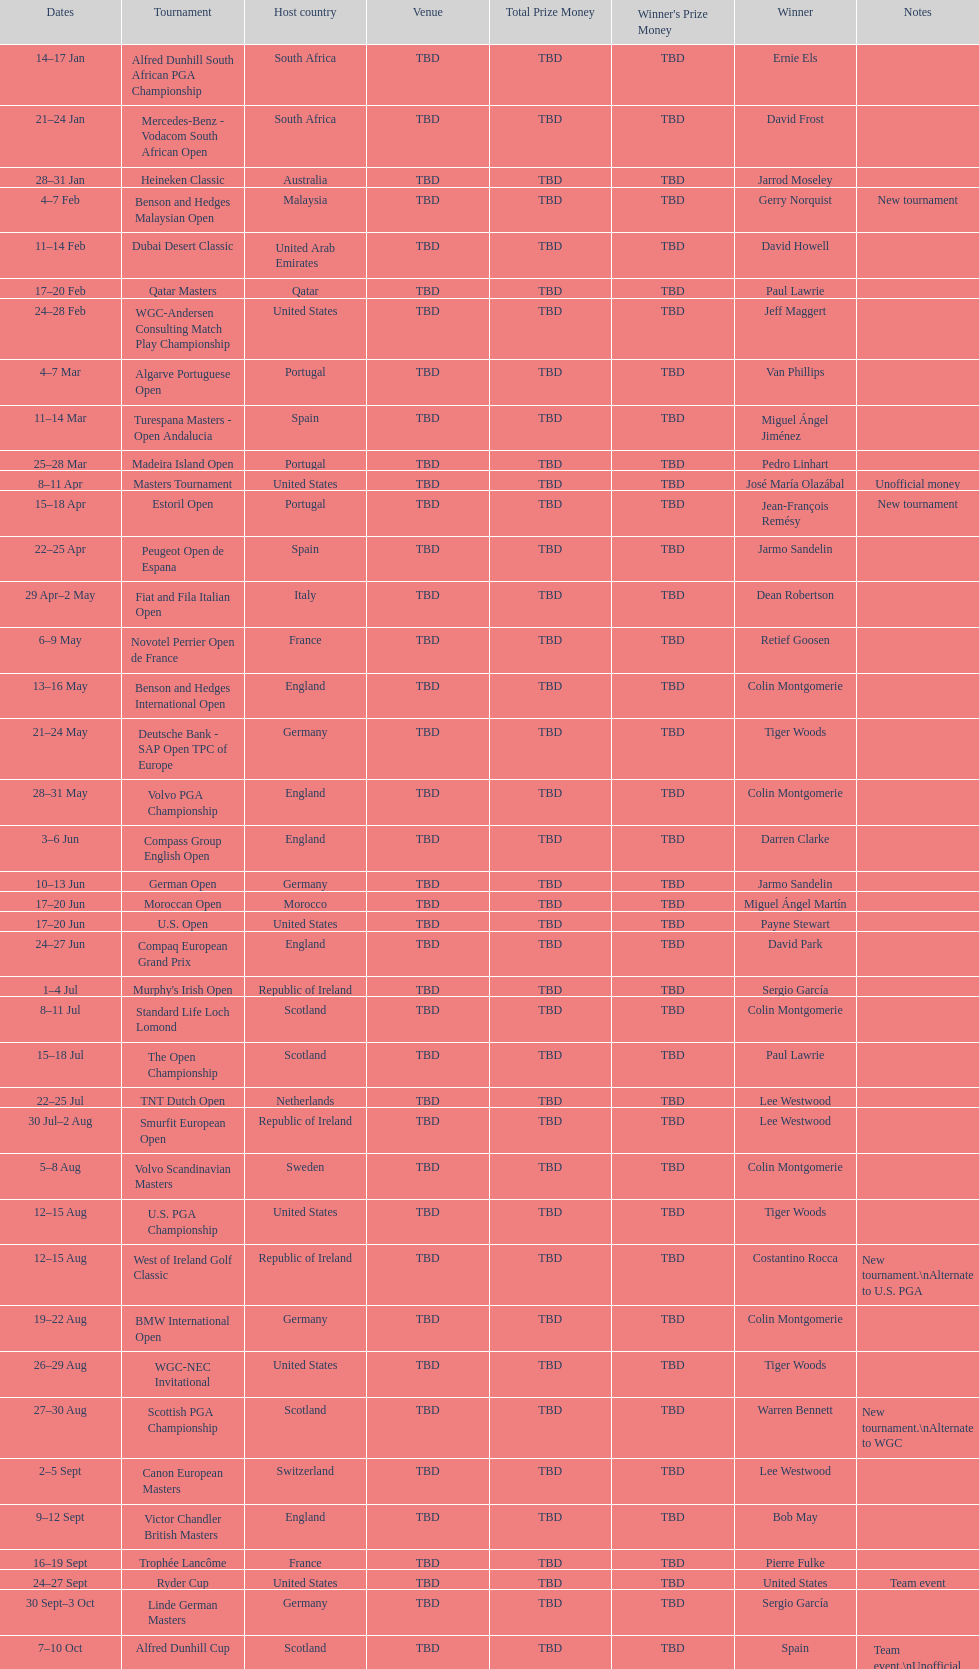Other than qatar masters, name a tournament that was in february. Dubai Desert Classic. 